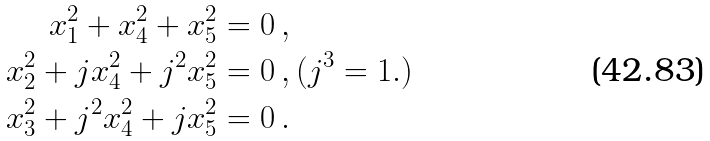<formula> <loc_0><loc_0><loc_500><loc_500>x _ { 1 } ^ { 2 } + x _ { 4 } ^ { 2 } + x _ { 5 } ^ { 2 } & = 0 \, , \\ x _ { 2 } ^ { 2 } + j x _ { 4 } ^ { 2 } + j ^ { 2 } x _ { 5 } ^ { 2 } & = 0 \, , ( j ^ { 3 } = 1 . ) \\ x _ { 3 } ^ { 2 } + j ^ { 2 } x _ { 4 } ^ { 2 } + j x _ { 5 } ^ { 2 } & = 0 \, .</formula> 